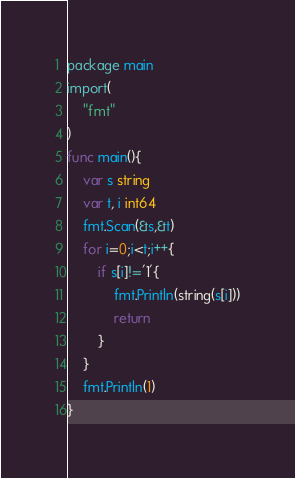Convert code to text. <code><loc_0><loc_0><loc_500><loc_500><_Go_>package main
import(
	"fmt"
)
func main(){
	var s string
	var t, i int64
	fmt.Scan(&s,&t)
	for i=0;i<t;i++{
		if s[i]!='1'{
			fmt.Println(string(s[i]))
			return
		}
	}
	fmt.Println(1)
}
</code> 